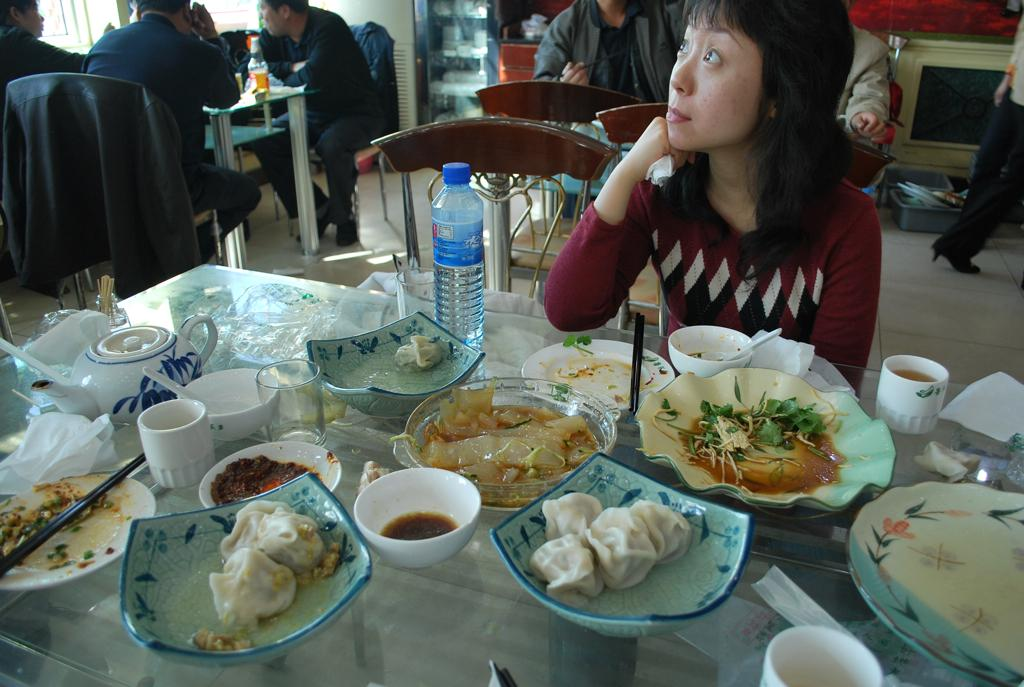What type of tableware can be seen in the image? There are plates, cups, and spoons in the image. What else is present on the table besides tableware? There are food items and tissues on the table. What is the purpose of the tissues in the image? The tissues might be used for wiping or cleaning purposes. Where are the people sitting in the image? The people are sitting at the table. How many pets are sitting with the people in the image? There are no pets present in the image; only people are sitting at the table. 